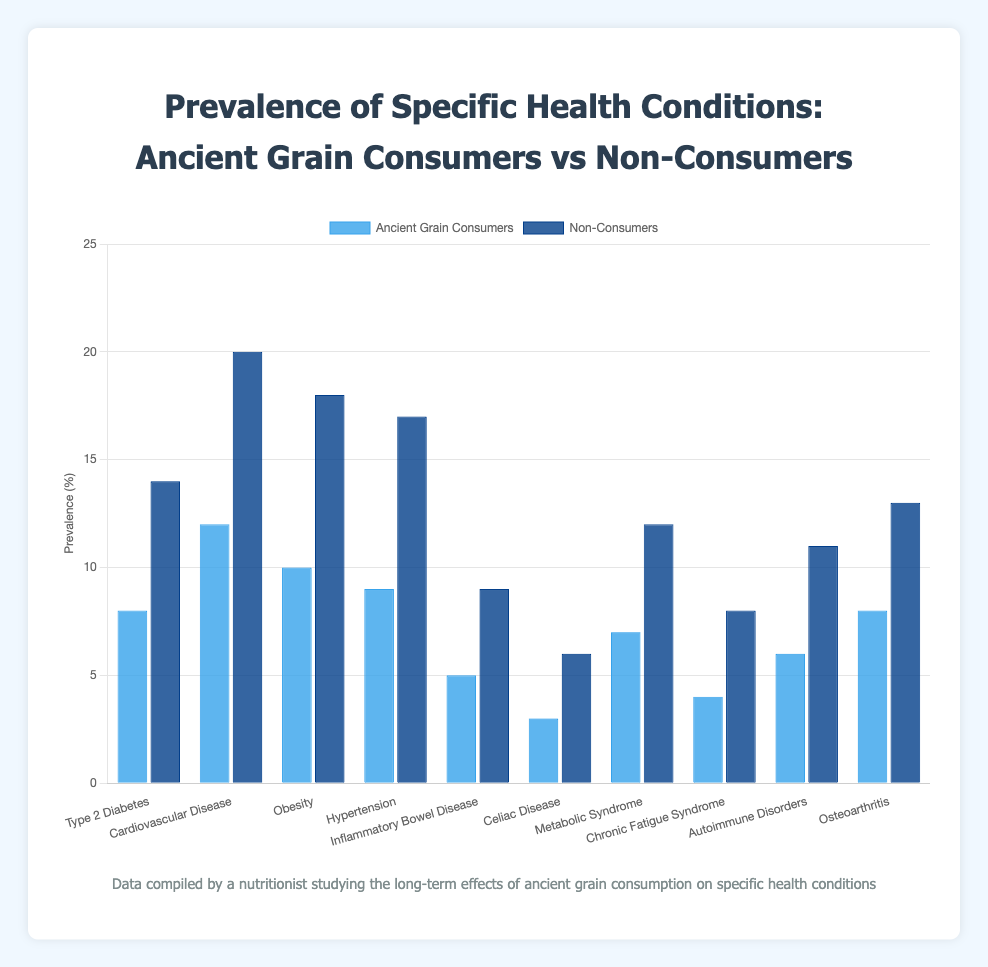What health condition had the lowest prevalence among ancient grain consumers? On the chart, the shortest bar for Ancient Grain Consumers corresponds to the health condition with the lowest prevalence. That bar is Inflammatory Bowel Disease with a prevalence of 5%.
Answer: Inflammatory Bowel Disease What is the difference in prevalence between ancient grain consumers and non-consumers for Type 2 Diabetes? Subtract the prevalence of Type 2 Diabetes among Ancient Grain Consumers (8%) from the prevalence among Non-Consumers (14%). So, 14 - 8 = 6%.
Answer: 6% Which health condition shows the greatest difference in prevalence between ancient grain consumers and non-consumers? Compare the differences in prevalence for each health condition. The largest difference is for Cardiovascular Disease between ancient grain consumers (12%) and non-consumers (20%), which is 20 - 12 = 8%.
Answer: Cardiovascular Disease What is the average prevalence of Obesity for both ancient grain consumers and non-consumers? Add the prevalences for Obesity (10% for consumers and 18% for non-consumers) and divide by 2. That is (10 + 18) / 2 = 14%.
Answer: 14% Which group shows a higher prevalence of Celiac Disease? Compare the heights of the bars for Celiac Disease. The bar for Non-Consumers is taller at 6%, compared to 3% for Ancient Grain Consumers.
Answer: Non-Consumers By how much does the prevalence of Hypertension among non-consumers exceed the prevalence among consumers? Subtract the prevalence of Hypertension among Ancient Grain Consumers (9%) from the prevalence among Non-Consumers (17%). So, 17 - 9 = 8%.
Answer: 8% List all health conditions where non-consumers have a higher prevalence compared to ancient grain consumers. Identify health conditions by visually comparing the heights of bars for each condition. Non-consumers have a higher prevalence in all conditions: Type 2 Diabetes, Cardiovascular Disease, Obesity, Hypertension, Inflammatory Bowel Disease, Celiac Disease, Metabolic Syndrome, Chronic Fatigue Syndrome, Autoimmune Disorders, and Osteoarthritis.
Answer: All health conditions What is the total prevalence of Autoimmune Disorders among both groups combined? Add the prevalence of Autoimmune Disorders for Ancient Grain Consumers (6%) and Non-Consumers (11%). That is 6 + 11 = 17%.
Answer: 17% Is the prevalence of Type 2 Diabetes or Hypertension higher among ancient grain consumers? Compare the heights of the bars for Type 2 Diabetes and Hypertension among Ancient Grain Consumers. Hypertension has a prevalence of 9%, which is higher than 8% for Type 2 Diabetes.
Answer: Hypertension How does the prevalence of Metabolic Syndrome among ancient grain consumers compare to that among non-consumers? Compare the heights of the bars for Metabolic Syndrome. The bar for Non-Consumers at 12% is taller than the bar for Ancient Grain Consumers at 7%.
Answer: Non-Consumers have a higher prevalence 